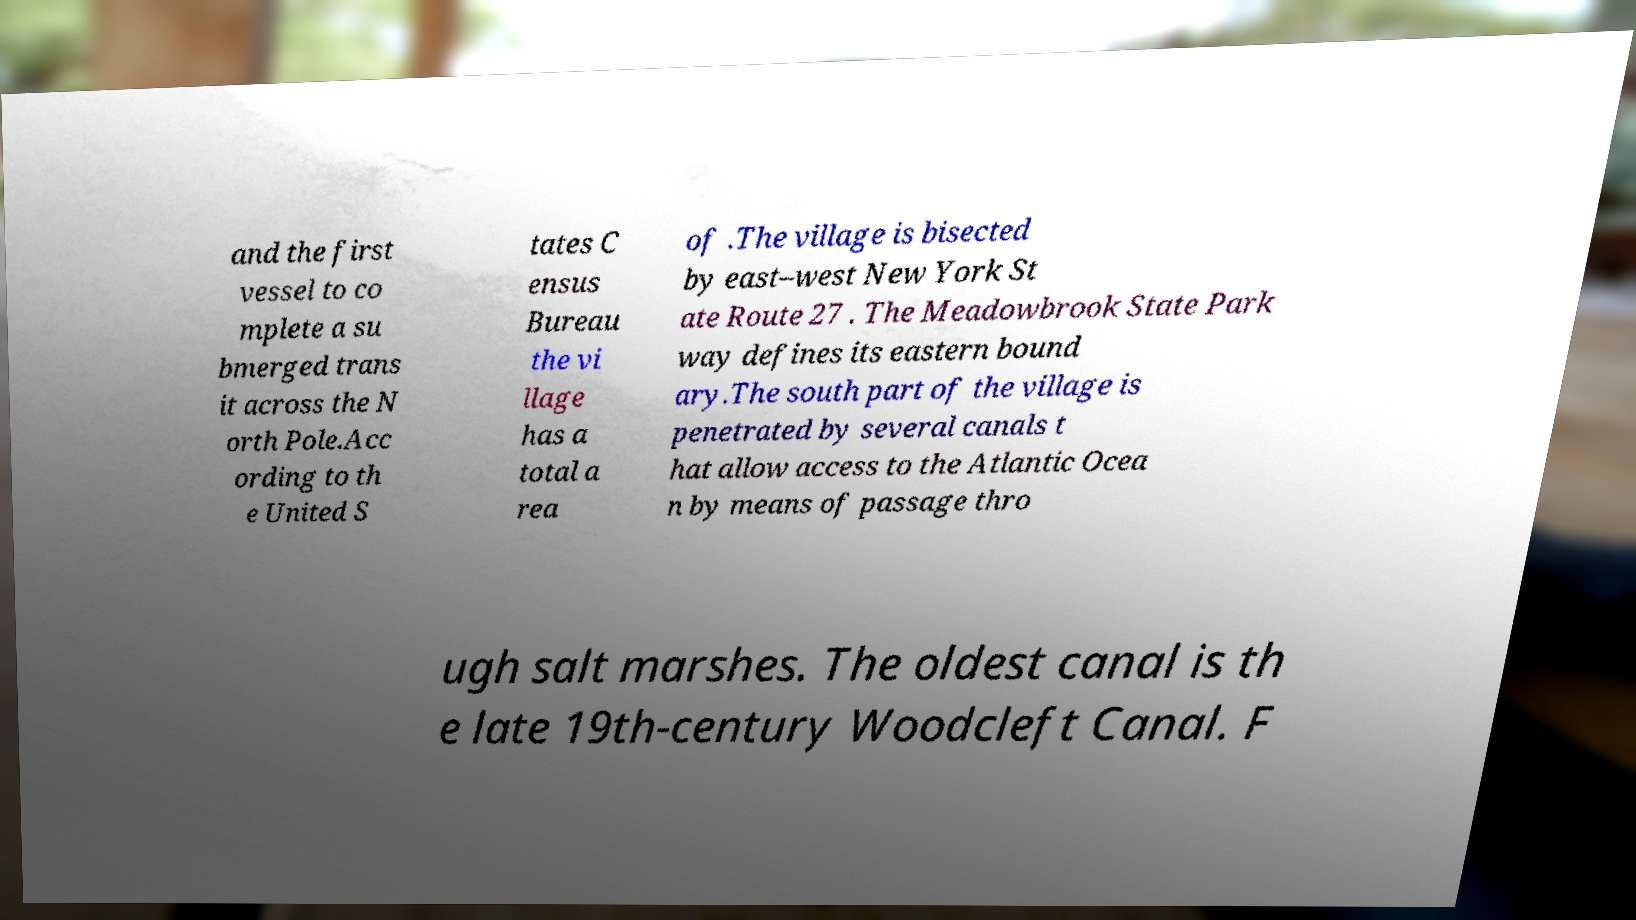Can you read and provide the text displayed in the image?This photo seems to have some interesting text. Can you extract and type it out for me? and the first vessel to co mplete a su bmerged trans it across the N orth Pole.Acc ording to th e United S tates C ensus Bureau the vi llage has a total a rea of .The village is bisected by east–west New York St ate Route 27 . The Meadowbrook State Park way defines its eastern bound ary.The south part of the village is penetrated by several canals t hat allow access to the Atlantic Ocea n by means of passage thro ugh salt marshes. The oldest canal is th e late 19th-century Woodcleft Canal. F 